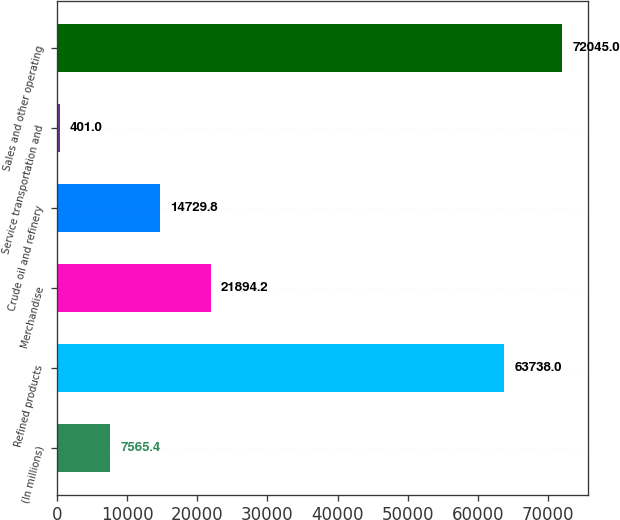Convert chart to OTSL. <chart><loc_0><loc_0><loc_500><loc_500><bar_chart><fcel>(In millions)<fcel>Refined products<fcel>Merchandise<fcel>Crude oil and refinery<fcel>Service transportation and<fcel>Sales and other operating<nl><fcel>7565.4<fcel>63738<fcel>21894.2<fcel>14729.8<fcel>401<fcel>72045<nl></chart> 